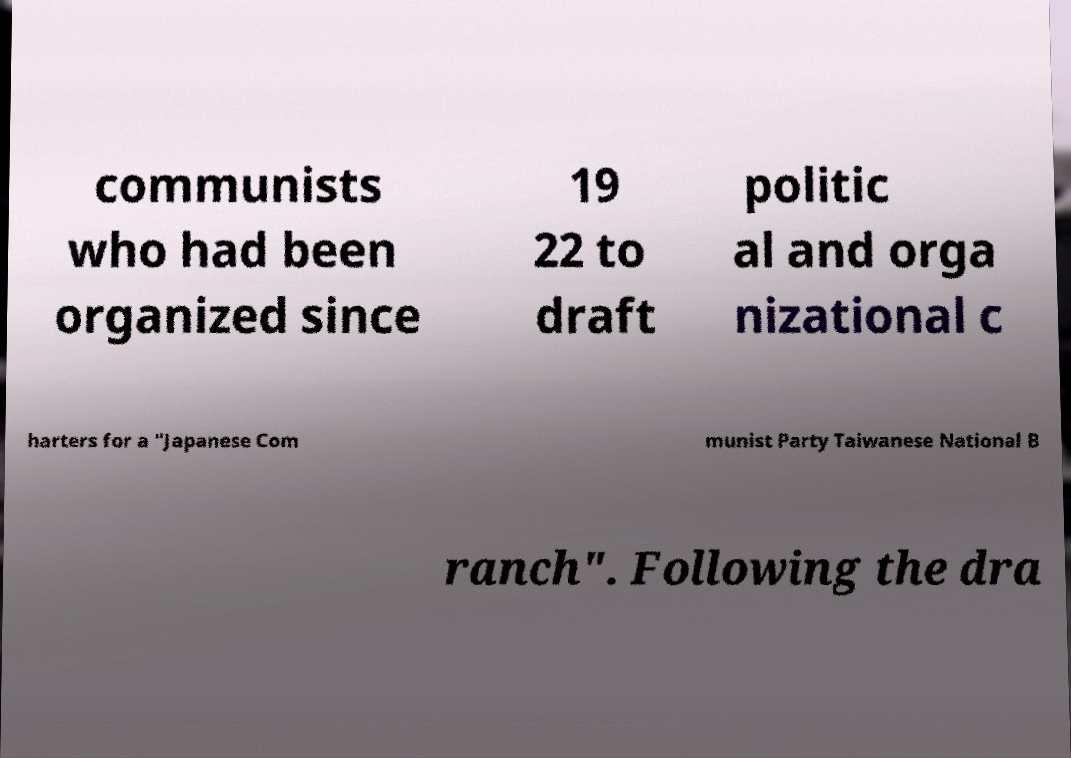For documentation purposes, I need the text within this image transcribed. Could you provide that? communists who had been organized since 19 22 to draft politic al and orga nizational c harters for a "Japanese Com munist Party Taiwanese National B ranch". Following the dra 